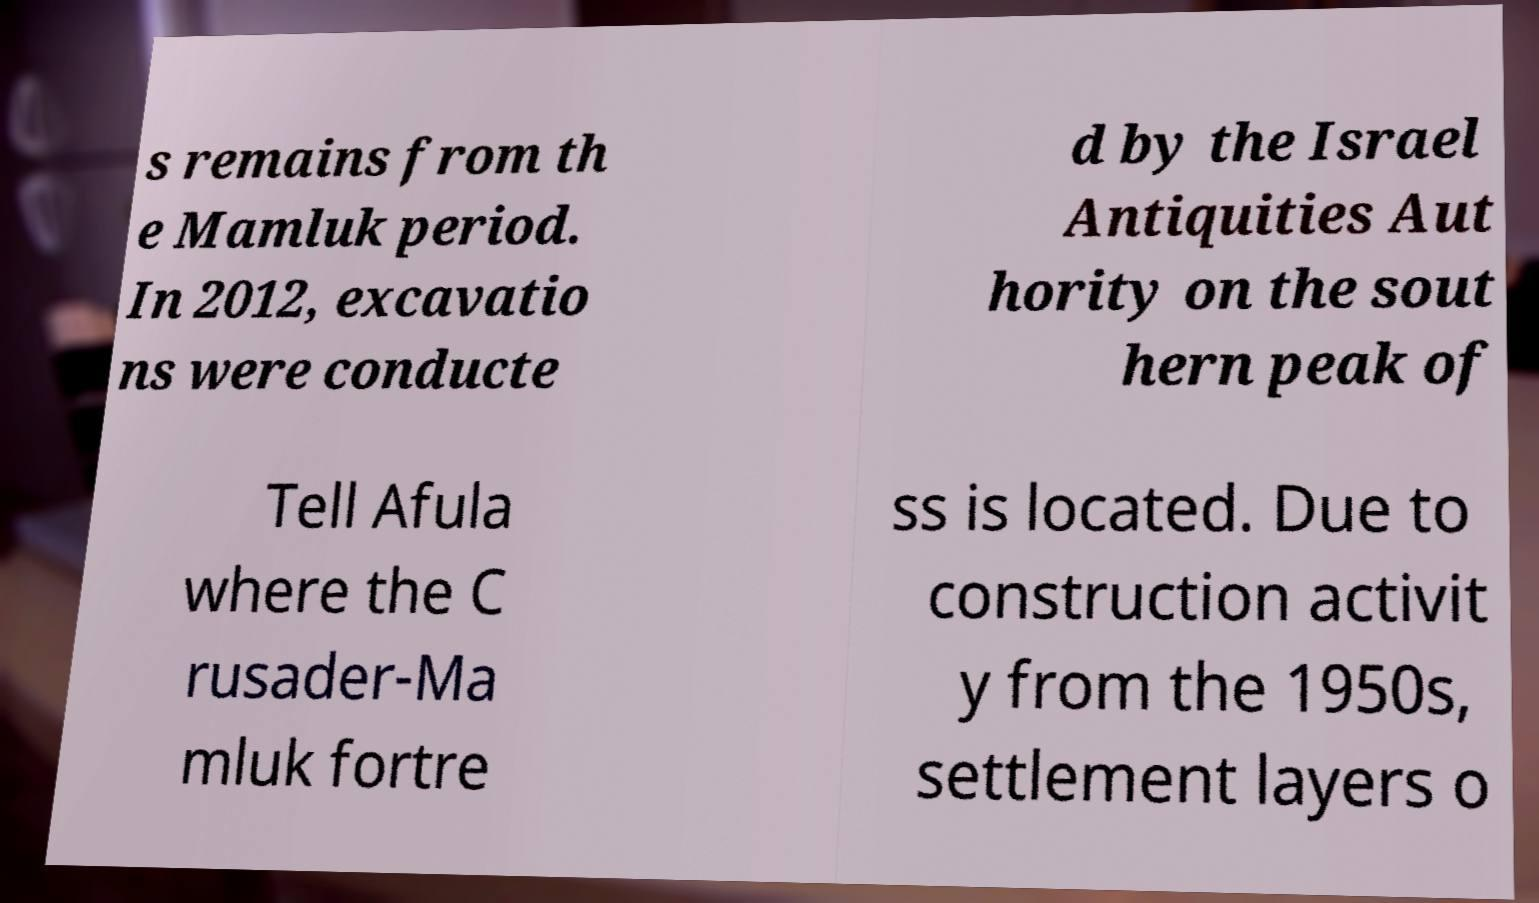There's text embedded in this image that I need extracted. Can you transcribe it verbatim? s remains from th e Mamluk period. In 2012, excavatio ns were conducte d by the Israel Antiquities Aut hority on the sout hern peak of Tell Afula where the C rusader-Ma mluk fortre ss is located. Due to construction activit y from the 1950s, settlement layers o 